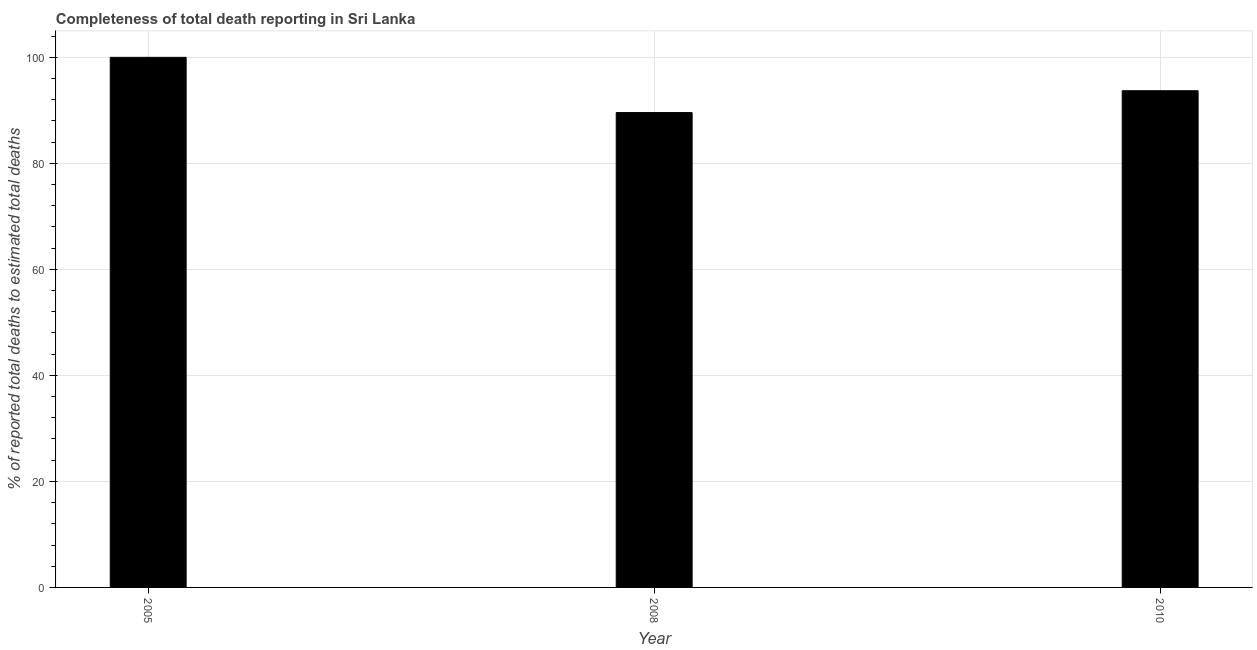Does the graph contain any zero values?
Keep it short and to the point. No. Does the graph contain grids?
Your answer should be compact. Yes. What is the title of the graph?
Make the answer very short. Completeness of total death reporting in Sri Lanka. What is the label or title of the X-axis?
Offer a very short reply. Year. What is the label or title of the Y-axis?
Your answer should be compact. % of reported total deaths to estimated total deaths. What is the completeness of total death reports in 2008?
Offer a terse response. 89.58. Across all years, what is the minimum completeness of total death reports?
Offer a very short reply. 89.58. In which year was the completeness of total death reports minimum?
Make the answer very short. 2008. What is the sum of the completeness of total death reports?
Make the answer very short. 283.28. What is the difference between the completeness of total death reports in 2008 and 2010?
Ensure brevity in your answer.  -4.12. What is the average completeness of total death reports per year?
Your response must be concise. 94.43. What is the median completeness of total death reports?
Ensure brevity in your answer.  93.7. In how many years, is the completeness of total death reports greater than 56 %?
Offer a terse response. 3. What is the ratio of the completeness of total death reports in 2005 to that in 2008?
Make the answer very short. 1.12. What is the difference between the highest and the second highest completeness of total death reports?
Your answer should be very brief. 6.3. What is the difference between the highest and the lowest completeness of total death reports?
Ensure brevity in your answer.  10.42. How many years are there in the graph?
Your response must be concise. 3. What is the % of reported total deaths to estimated total deaths in 2005?
Your answer should be very brief. 100. What is the % of reported total deaths to estimated total deaths of 2008?
Keep it short and to the point. 89.58. What is the % of reported total deaths to estimated total deaths in 2010?
Keep it short and to the point. 93.7. What is the difference between the % of reported total deaths to estimated total deaths in 2005 and 2008?
Offer a terse response. 10.42. What is the difference between the % of reported total deaths to estimated total deaths in 2005 and 2010?
Your response must be concise. 6.3. What is the difference between the % of reported total deaths to estimated total deaths in 2008 and 2010?
Provide a short and direct response. -4.12. What is the ratio of the % of reported total deaths to estimated total deaths in 2005 to that in 2008?
Make the answer very short. 1.12. What is the ratio of the % of reported total deaths to estimated total deaths in 2005 to that in 2010?
Your answer should be compact. 1.07. What is the ratio of the % of reported total deaths to estimated total deaths in 2008 to that in 2010?
Your answer should be very brief. 0.96. 